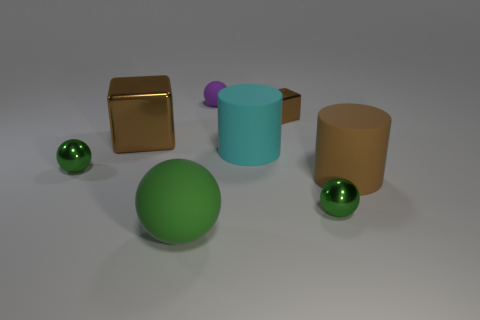Can you describe the spatial arrangement of the objects? Certainly! The image displays objects arranged on a flat surface with no discernible pattern. To the left, there's a small reflective sphere and behind it, slightly to the right, stands the metal cube with clear, sharp edges. The matte green sphere is centered in the foreground and commands attention due to its size and color. To its right, there are two cylinders: one closer and green with a purple object on top, the other, larger and brown. Another smaller shiny sphere is situated in close proximity to the brown cylinder. 